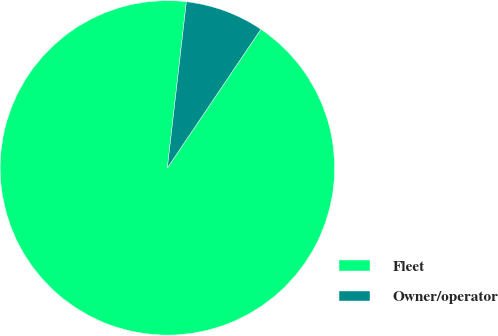Convert chart to OTSL. <chart><loc_0><loc_0><loc_500><loc_500><pie_chart><fcel>Fleet<fcel>Owner/operator<nl><fcel>92.37%<fcel>7.63%<nl></chart> 